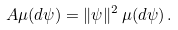Convert formula to latex. <formula><loc_0><loc_0><loc_500><loc_500>A \mu ( d \psi ) = \| \psi \| ^ { 2 } \, \mu ( d \psi ) \, .</formula> 